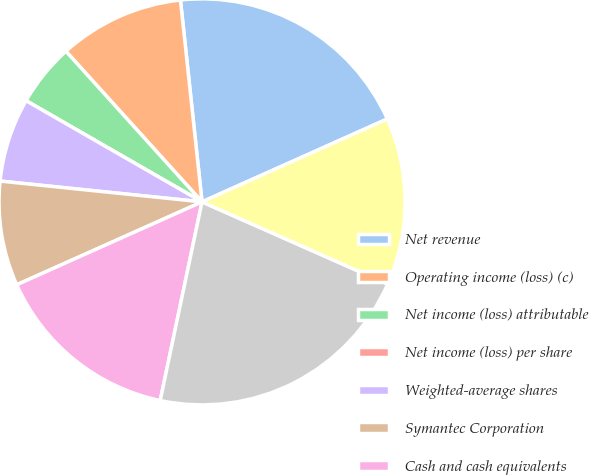<chart> <loc_0><loc_0><loc_500><loc_500><pie_chart><fcel>Net revenue<fcel>Operating income (loss) (c)<fcel>Net income (loss) attributable<fcel>Net income (loss) per share<fcel>Weighted-average shares<fcel>Symantec Corporation<fcel>Cash and cash equivalents<fcel>Total assets (c)<fcel>Deferred revenue<nl><fcel>20.0%<fcel>10.0%<fcel>5.0%<fcel>0.0%<fcel>6.67%<fcel>8.33%<fcel>15.0%<fcel>21.67%<fcel>13.33%<nl></chart> 